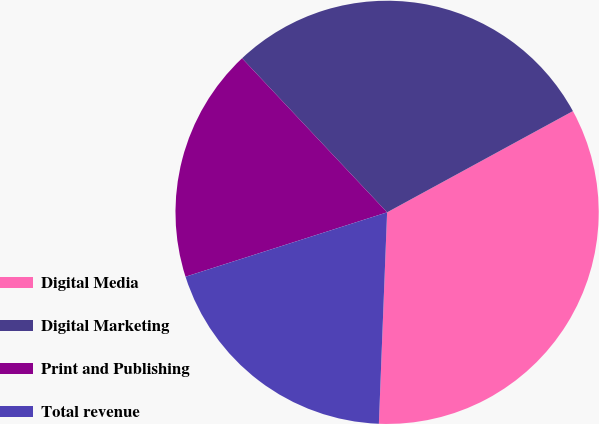<chart> <loc_0><loc_0><loc_500><loc_500><pie_chart><fcel>Digital Media<fcel>Digital Marketing<fcel>Print and Publishing<fcel>Total revenue<nl><fcel>33.56%<fcel>29.08%<fcel>17.9%<fcel>19.46%<nl></chart> 